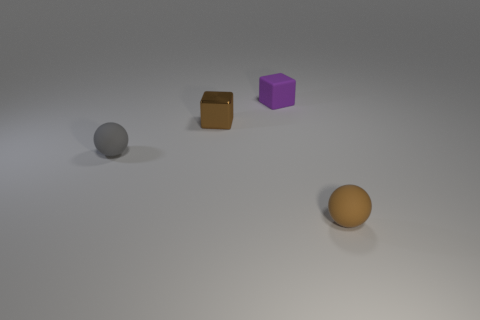How many small gray matte things are the same shape as the brown rubber object?
Offer a terse response. 1. There is a tiny object right of the purple matte block; is its color the same as the tiny shiny block?
Offer a very short reply. Yes. Is the color of the tiny ball that is right of the tiny brown metal block the same as the cube to the left of the small matte block?
Your response must be concise. Yes. Are there any purple cubes that have the same material as the tiny purple object?
Your answer should be compact. No. How many brown things are either blocks or balls?
Provide a short and direct response. 2. Is the number of matte balls to the left of the small purple matte thing greater than the number of matte cylinders?
Your answer should be compact. Yes. Is the size of the gray matte sphere the same as the shiny block?
Make the answer very short. Yes. There is another small sphere that is the same material as the small gray ball; what is its color?
Your answer should be very brief. Brown. There is a tiny matte thing that is the same color as the shiny object; what shape is it?
Provide a short and direct response. Sphere. Are there an equal number of rubber things to the right of the metal cube and small gray matte balls that are on the left side of the tiny purple rubber cube?
Offer a very short reply. No. 